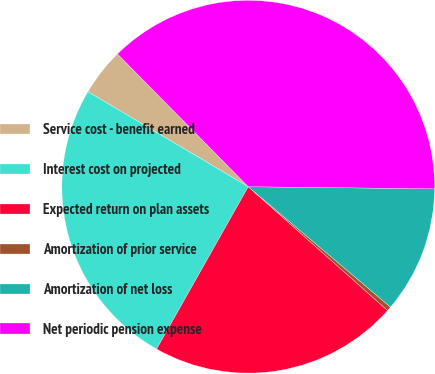Convert chart. <chart><loc_0><loc_0><loc_500><loc_500><pie_chart><fcel>Service cost - benefit earned<fcel>Interest cost on projected<fcel>Expected return on plan assets<fcel>Amortization of prior service<fcel>Amortization of net loss<fcel>Net periodic pension expense<nl><fcel>4.1%<fcel>25.34%<fcel>21.62%<fcel>0.38%<fcel>11.0%<fcel>37.56%<nl></chart> 